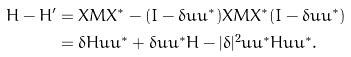<formula> <loc_0><loc_0><loc_500><loc_500>H - H ^ { \prime } & = X M X ^ { * } - ( I - \delta u u ^ { * } ) X M X ^ { * } ( I - \bar { \delta } u u ^ { * } ) \\ & = \delta H u u ^ { * } + \bar { \delta } u u ^ { * } H - | \delta | ^ { 2 } u u ^ { * } H u u ^ { * } .</formula> 